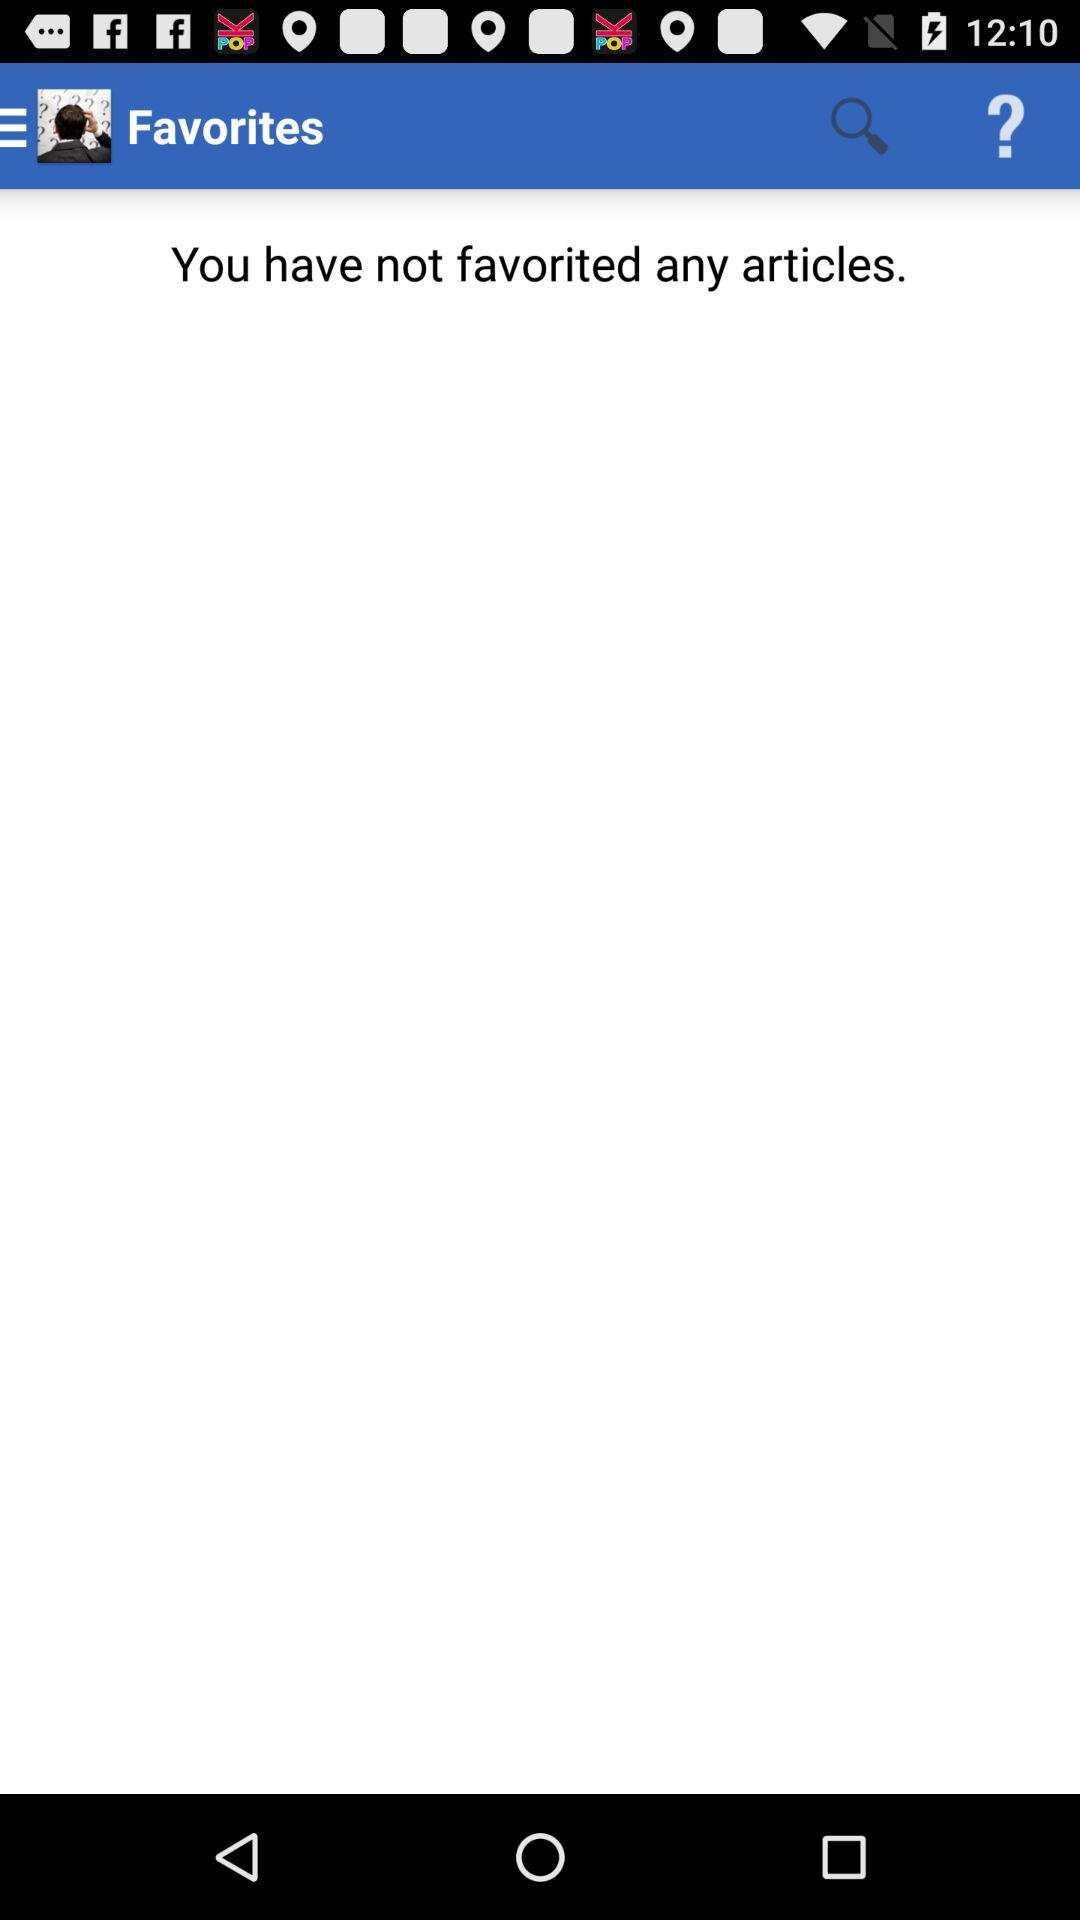How many articles have I favorited?
Answer the question using a single word or phrase. 0 